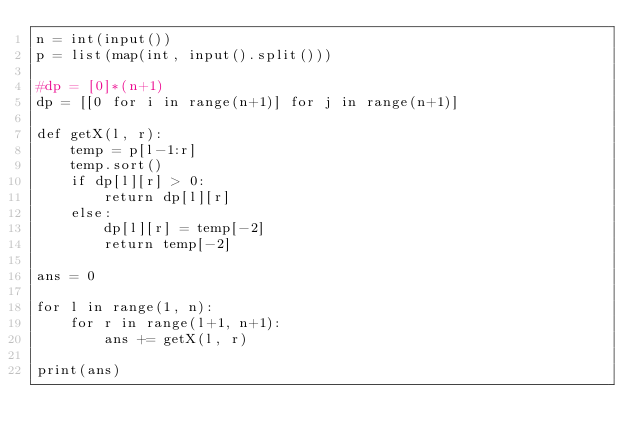Convert code to text. <code><loc_0><loc_0><loc_500><loc_500><_Python_>n = int(input())
p = list(map(int, input().split()))

#dp = [0]*(n+1)
dp = [[0 for i in range(n+1)] for j in range(n+1)]

def getX(l, r):
    temp = p[l-1:r]
    temp.sort()
    if dp[l][r] > 0:
        return dp[l][r]
    else:
        dp[l][r] = temp[-2]
        return temp[-2]

ans = 0

for l in range(1, n):
    for r in range(l+1, n+1):
        ans += getX(l, r)

print(ans)
</code> 